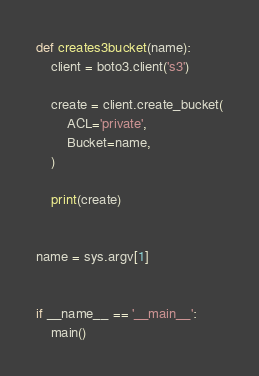<code> <loc_0><loc_0><loc_500><loc_500><_Python_>
def creates3bucket(name):
    client = boto3.client('s3')

    create = client.create_bucket(
        ACL='private',
        Bucket=name,
    )

    print(create)


name = sys.argv[1]


if __name__ == '__main__':
    main()</code> 